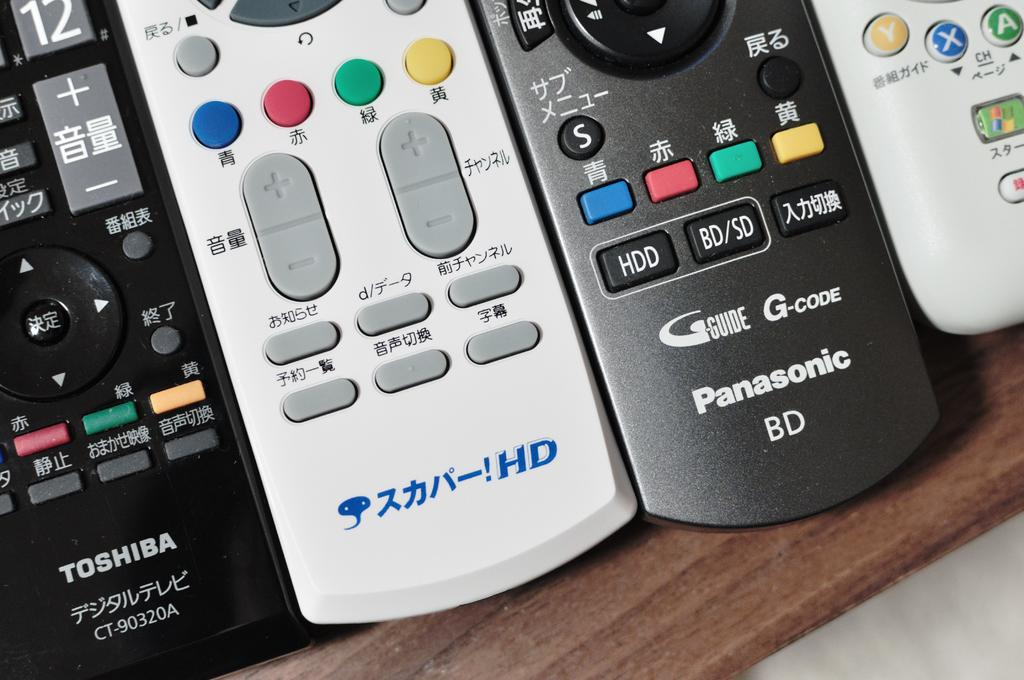<image>
Summarize the visual content of the image. a few remotes with the words Panasonic on them 